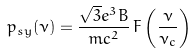Convert formula to latex. <formula><loc_0><loc_0><loc_500><loc_500>p _ { s y } ( \nu ) = \frac { \sqrt { 3 } e ^ { 3 } B } { m c ^ { 2 } } \, F \left ( \frac { \nu } { \nu _ { c } } \right )</formula> 